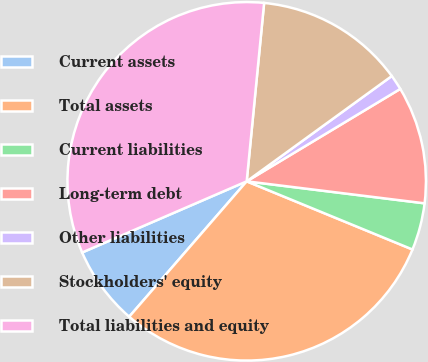Convert chart. <chart><loc_0><loc_0><loc_500><loc_500><pie_chart><fcel>Current assets<fcel>Total assets<fcel>Current liabilities<fcel>Long-term debt<fcel>Other liabilities<fcel>Stockholders' equity<fcel>Total liabilities and equity<nl><fcel>7.13%<fcel>30.17%<fcel>4.25%<fcel>10.58%<fcel>1.37%<fcel>13.46%<fcel>33.05%<nl></chart> 